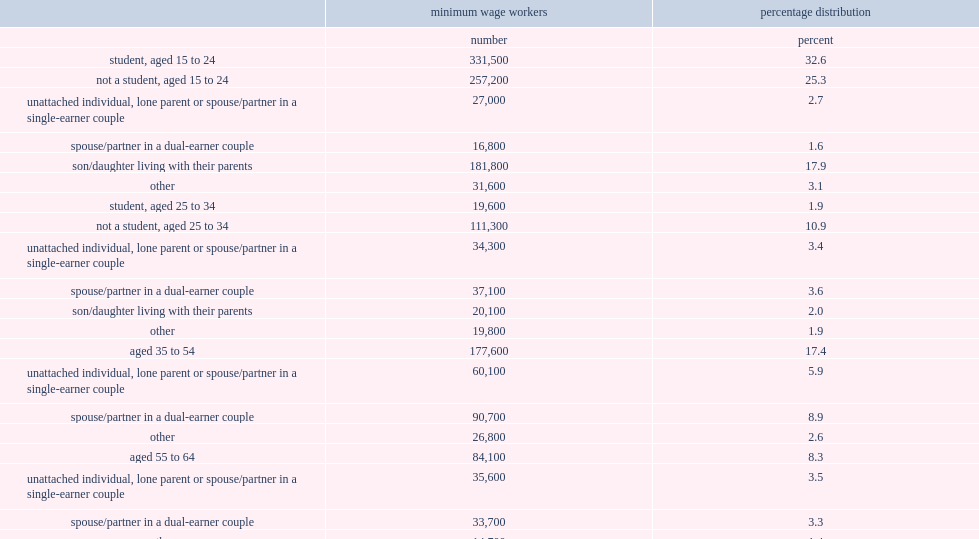How many individuals in total earned minimum wages in 2017? 1018100.0. What was the total proportion of students aged 15 to 24 and non-students at the same age living with their parents among all individuals that earned minimum wages in 2017? 0.578234. What was the proportion of minimum wage workers in 2017 that were under 65 and unattached individuals, lone parents or spouses/partners in single-earner couples? 0.154209. What was the proportion of minimum wage workers in 2017 that were under 65 and spouses/partners in dual-earner couples? 0.17513. What was the total proportion of students aged 15 to 24 and non-students the same age living with their parents; individuals aged 15 to 64 who were single, lone parents or spouses/partners in single-earner couples; and individuals aged 15 to 64 who were spouses/partners in dual-earner couples? 0.907573. 